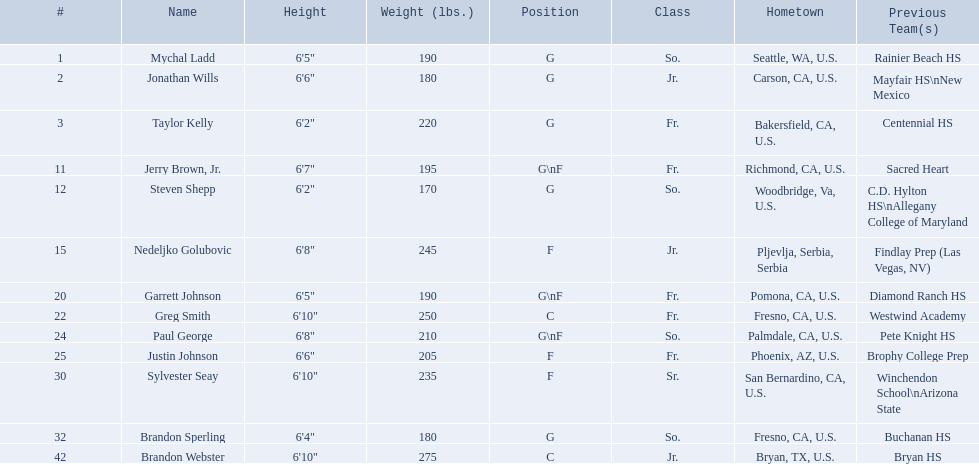Who are all the participants? Mychal Ladd, Jonathan Wills, Taylor Kelly, Jerry Brown, Jr., Steven Shepp, Nedeljko Golubovic, Garrett Johnson, Greg Smith, Paul George, Justin Johnson, Sylvester Seay, Brandon Sperling, Brandon Webster. What are their statures? 6'5", 6'6", 6'2", 6'7", 6'2", 6'8", 6'5", 6'10", 6'8", 6'6", 6'10", 6'4", 6'10". Besides taylor kelly, which additional player is below 6'3 in height? Steven Shepp. 